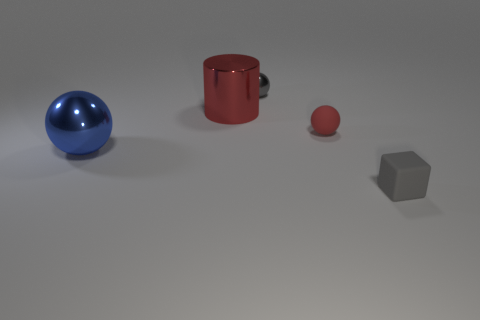Is the metallic cylinder the same size as the blue metal ball?
Your response must be concise. Yes. How many other things are there of the same shape as the tiny gray matte object?
Give a very brief answer. 0. What is the shape of the tiny matte thing that is behind the gray cube?
Provide a succinct answer. Sphere. Is the shape of the metal thing that is in front of the cylinder the same as the red object that is to the right of the tiny gray ball?
Your answer should be very brief. Yes. Is the number of big red things to the right of the gray metallic thing the same as the number of large yellow matte blocks?
Give a very brief answer. Yes. What is the material of the red thing that is the same shape as the gray metal object?
Your answer should be compact. Rubber. What is the shape of the rubber thing on the right side of the red thing that is to the right of the gray shiny thing?
Give a very brief answer. Cube. Is the small gray object behind the tiny gray matte block made of the same material as the small red sphere?
Keep it short and to the point. No. Are there an equal number of spheres to the left of the small gray metallic thing and large cylinders that are on the right side of the blue thing?
Provide a succinct answer. Yes. There is a thing that is the same color as the cube; what is it made of?
Give a very brief answer. Metal. 